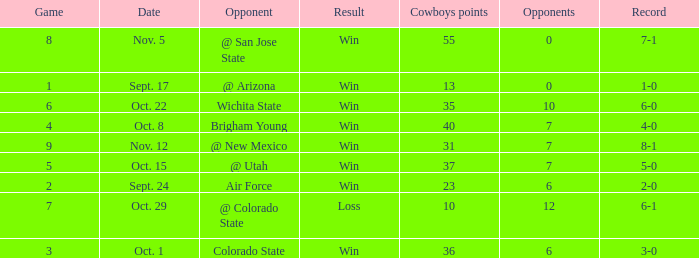What was the Cowboys' record for Nov. 5, 1966? 7-1. 